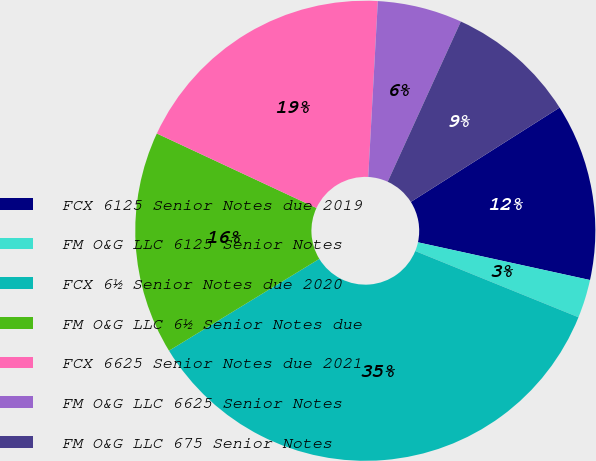Convert chart. <chart><loc_0><loc_0><loc_500><loc_500><pie_chart><fcel>FCX 6125 Senior Notes due 2019<fcel>FM O&G LLC 6125 Senior Notes<fcel>FCX 6½ Senior Notes due 2020<fcel>FM O&G LLC 6½ Senior Notes due<fcel>FCX 6625 Senior Notes due 2021<fcel>FM O&G LLC 6625 Senior Notes<fcel>FM O&G LLC 675 Senior Notes<nl><fcel>12.43%<fcel>2.7%<fcel>35.14%<fcel>15.68%<fcel>18.92%<fcel>5.95%<fcel>9.19%<nl></chart> 